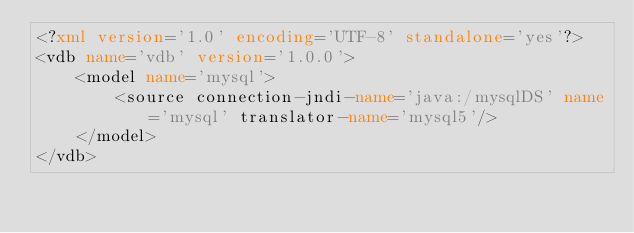Convert code to text. <code><loc_0><loc_0><loc_500><loc_500><_XML_><?xml version='1.0' encoding='UTF-8' standalone='yes'?>
<vdb name='vdb' version='1.0.0'>
    <model name='mysql'>
        <source connection-jndi-name='java:/mysqlDS' name='mysql' translator-name='mysql5'/>
    </model>
</vdb>
</code> 